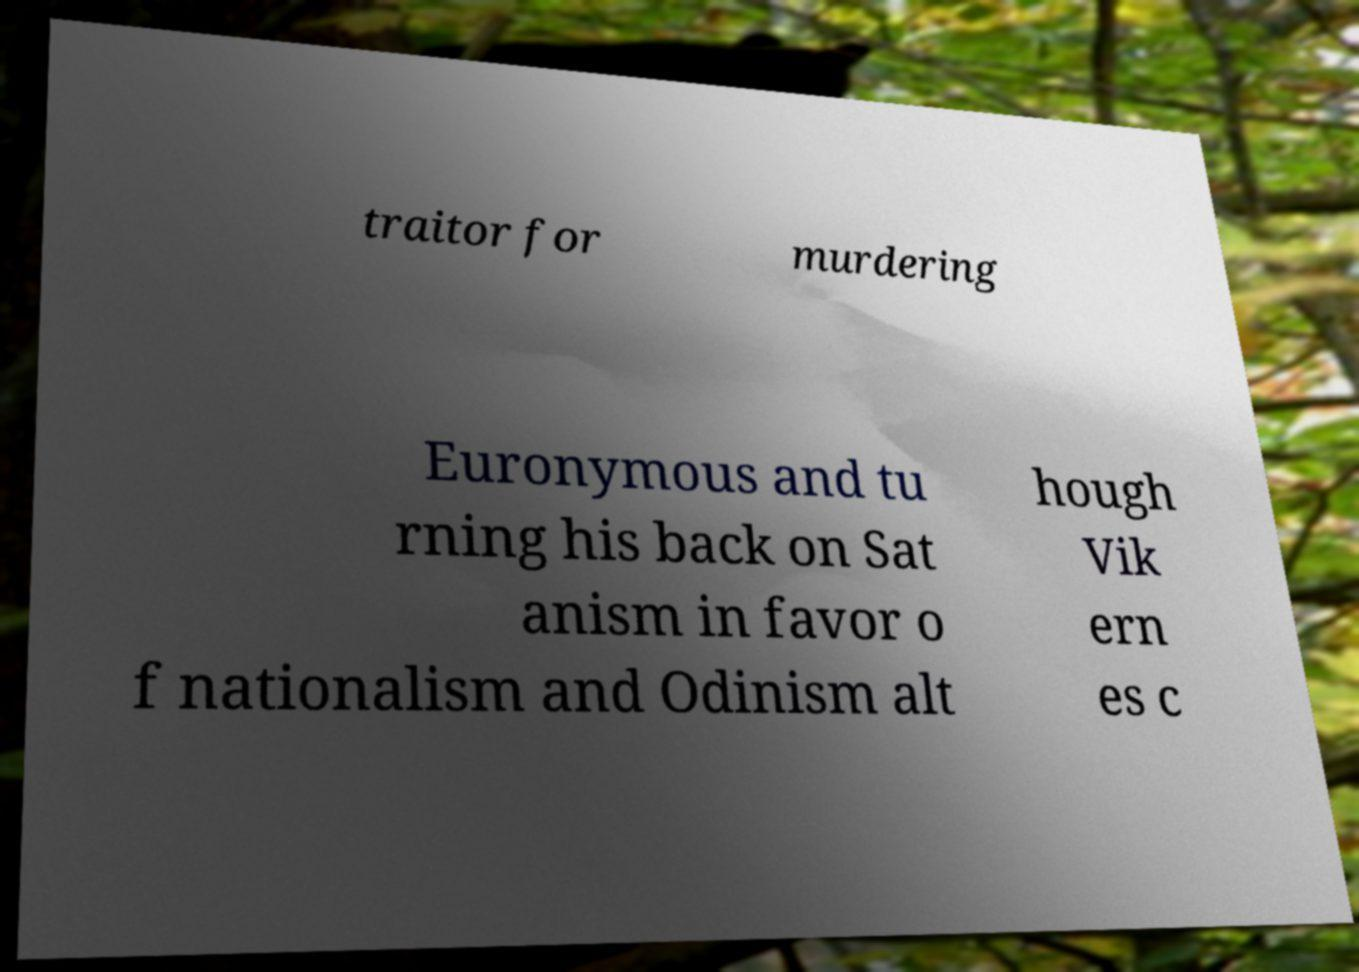Can you accurately transcribe the text from the provided image for me? traitor for murdering Euronymous and tu rning his back on Sat anism in favor o f nationalism and Odinism alt hough Vik ern es c 